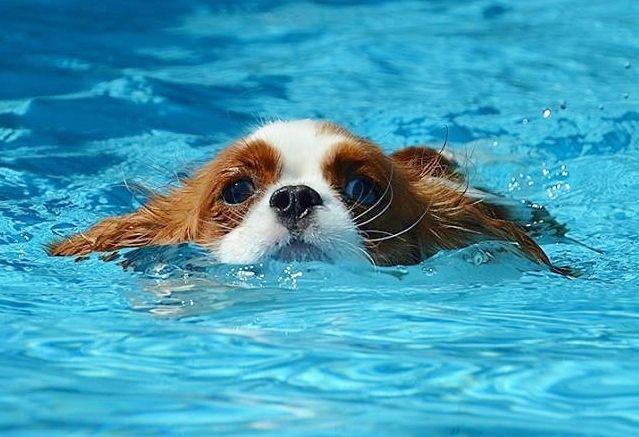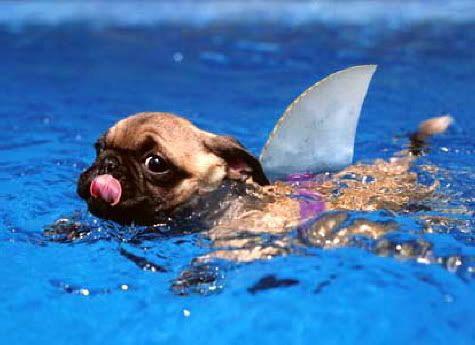The first image is the image on the left, the second image is the image on the right. Considering the images on both sides, is "Left image shows a dog swimming leftward." valid? Answer yes or no. No. The first image is the image on the left, the second image is the image on the right. Analyze the images presented: Is the assertion "There is a brown and white cocker spaniel swimming in a pool" valid? Answer yes or no. Yes. 